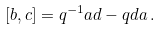Convert formula to latex. <formula><loc_0><loc_0><loc_500><loc_500>[ b , c ] = q ^ { - 1 } a d - q d a \, .</formula> 